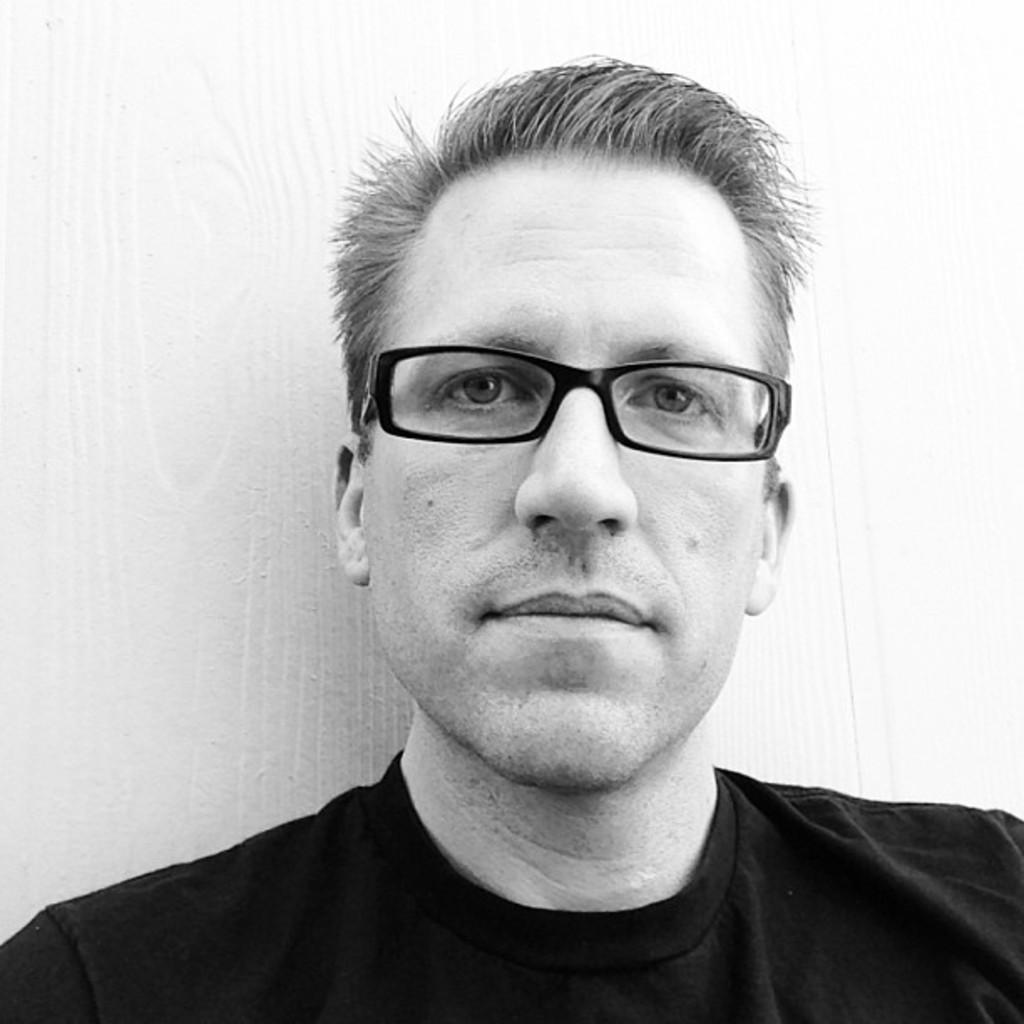Who is present in the image? There is a man in the image. What is the man wearing on his face? The man is wearing glasses (specs) in the image. What type of clothing is the man wearing on his upper body? The man is wearing a t-shirt in the image. What is the color scheme of the image? The image is black and white in color. What key is the man using to unlock the door in the image? There is no door or key present in the image; it only features a man wearing glasses and a t-shirt in a black and white setting. 